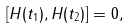Convert formula to latex. <formula><loc_0><loc_0><loc_500><loc_500>[ H ( t _ { 1 } ) , H ( t _ { 2 } ) ] = 0 ,</formula> 